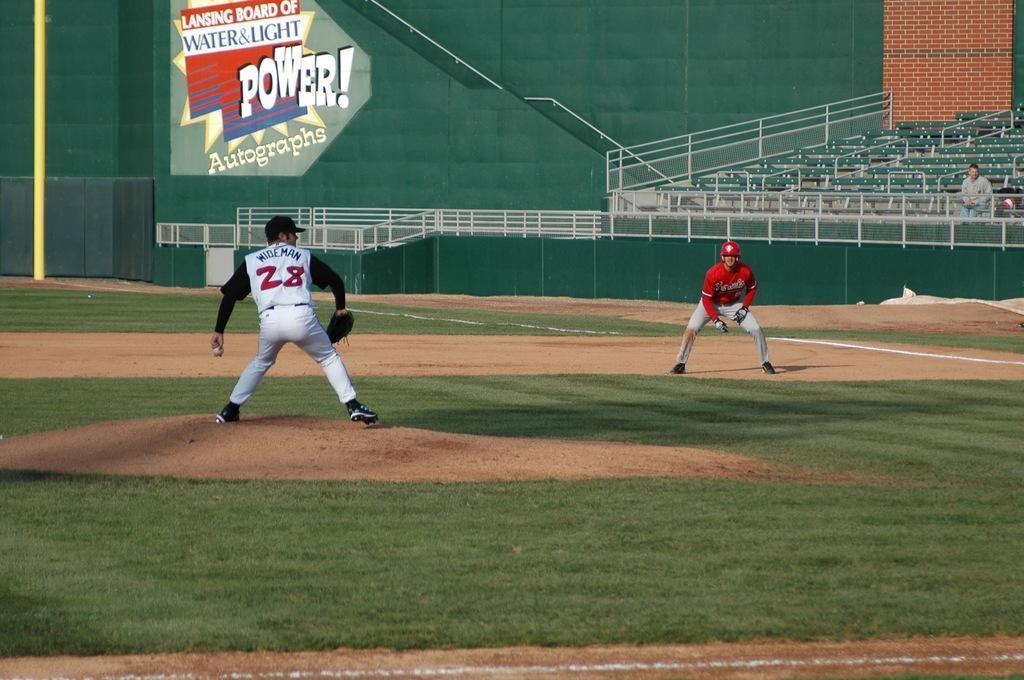Can you describe this image briefly? In this image I can see two persons playing in the ground. There is some grass on the ground. In the background I can see few chairs. I can see a person sitting on the chair. At the top there is some text. 